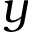<formula> <loc_0><loc_0><loc_500><loc_500>y</formula> 